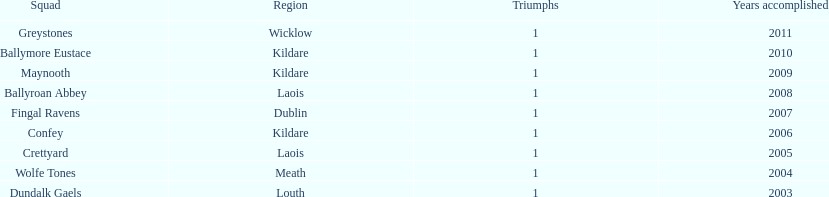Could you help me parse every detail presented in this table? {'header': ['Squad', 'Region', 'Triumphs', 'Years accomplished'], 'rows': [['Greystones', 'Wicklow', '1', '2011'], ['Ballymore Eustace', 'Kildare', '1', '2010'], ['Maynooth', 'Kildare', '1', '2009'], ['Ballyroan Abbey', 'Laois', '1', '2008'], ['Fingal Ravens', 'Dublin', '1', '2007'], ['Confey', 'Kildare', '1', '2006'], ['Crettyard', 'Laois', '1', '2005'], ['Wolfe Tones', 'Meath', '1', '2004'], ['Dundalk Gaels', 'Louth', '1', '2003']]} What team comes before confey Fingal Ravens. 